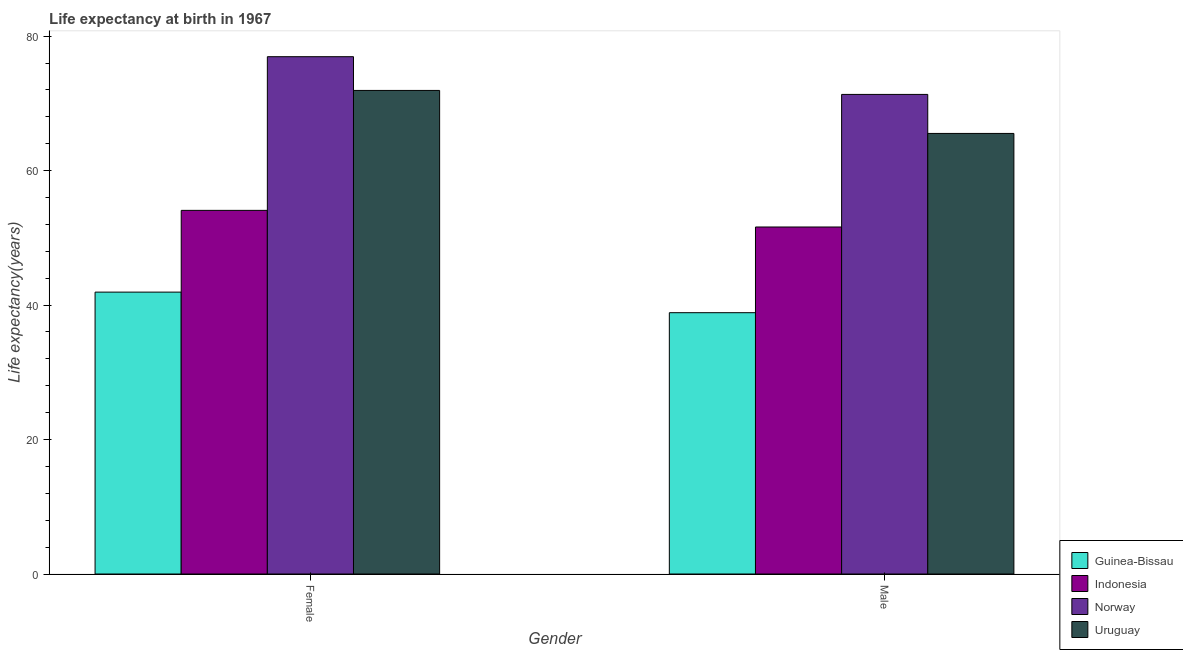How many groups of bars are there?
Provide a short and direct response. 2. What is the label of the 1st group of bars from the left?
Provide a short and direct response. Female. What is the life expectancy(female) in Uruguay?
Your answer should be very brief. 71.92. Across all countries, what is the maximum life expectancy(female)?
Offer a terse response. 76.94. Across all countries, what is the minimum life expectancy(female)?
Make the answer very short. 41.92. In which country was the life expectancy(female) minimum?
Give a very brief answer. Guinea-Bissau. What is the total life expectancy(female) in the graph?
Offer a terse response. 244.87. What is the difference between the life expectancy(male) in Norway and that in Uruguay?
Provide a short and direct response. 5.8. What is the difference between the life expectancy(female) in Guinea-Bissau and the life expectancy(male) in Norway?
Your answer should be very brief. -29.41. What is the average life expectancy(male) per country?
Ensure brevity in your answer.  56.83. What is the difference between the life expectancy(female) and life expectancy(male) in Indonesia?
Your answer should be compact. 2.47. What is the ratio of the life expectancy(male) in Uruguay to that in Guinea-Bissau?
Your response must be concise. 1.69. In how many countries, is the life expectancy(female) greater than the average life expectancy(female) taken over all countries?
Your response must be concise. 2. What does the 2nd bar from the right in Male represents?
Your answer should be very brief. Norway. Are all the bars in the graph horizontal?
Provide a short and direct response. No. Does the graph contain grids?
Keep it short and to the point. No. Where does the legend appear in the graph?
Offer a very short reply. Bottom right. How many legend labels are there?
Your response must be concise. 4. How are the legend labels stacked?
Your answer should be compact. Vertical. What is the title of the graph?
Offer a very short reply. Life expectancy at birth in 1967. What is the label or title of the X-axis?
Provide a succinct answer. Gender. What is the label or title of the Y-axis?
Ensure brevity in your answer.  Life expectancy(years). What is the Life expectancy(years) of Guinea-Bissau in Female?
Give a very brief answer. 41.92. What is the Life expectancy(years) in Indonesia in Female?
Give a very brief answer. 54.08. What is the Life expectancy(years) of Norway in Female?
Provide a short and direct response. 76.94. What is the Life expectancy(years) in Uruguay in Female?
Offer a terse response. 71.92. What is the Life expectancy(years) in Guinea-Bissau in Male?
Give a very brief answer. 38.86. What is the Life expectancy(years) of Indonesia in Male?
Ensure brevity in your answer.  51.61. What is the Life expectancy(years) in Norway in Male?
Your answer should be very brief. 71.33. What is the Life expectancy(years) of Uruguay in Male?
Offer a terse response. 65.53. Across all Gender, what is the maximum Life expectancy(years) of Guinea-Bissau?
Provide a succinct answer. 41.92. Across all Gender, what is the maximum Life expectancy(years) of Indonesia?
Give a very brief answer. 54.08. Across all Gender, what is the maximum Life expectancy(years) in Norway?
Give a very brief answer. 76.94. Across all Gender, what is the maximum Life expectancy(years) of Uruguay?
Provide a succinct answer. 71.92. Across all Gender, what is the minimum Life expectancy(years) in Guinea-Bissau?
Offer a very short reply. 38.86. Across all Gender, what is the minimum Life expectancy(years) in Indonesia?
Your answer should be very brief. 51.61. Across all Gender, what is the minimum Life expectancy(years) of Norway?
Offer a very short reply. 71.33. Across all Gender, what is the minimum Life expectancy(years) of Uruguay?
Your answer should be compact. 65.53. What is the total Life expectancy(years) in Guinea-Bissau in the graph?
Offer a very short reply. 80.79. What is the total Life expectancy(years) in Indonesia in the graph?
Your answer should be very brief. 105.69. What is the total Life expectancy(years) in Norway in the graph?
Provide a succinct answer. 148.27. What is the total Life expectancy(years) in Uruguay in the graph?
Give a very brief answer. 137.45. What is the difference between the Life expectancy(years) of Guinea-Bissau in Female and that in Male?
Your answer should be compact. 3.06. What is the difference between the Life expectancy(years) of Indonesia in Female and that in Male?
Ensure brevity in your answer.  2.47. What is the difference between the Life expectancy(years) of Norway in Female and that in Male?
Keep it short and to the point. 5.61. What is the difference between the Life expectancy(years) in Uruguay in Female and that in Male?
Provide a short and direct response. 6.39. What is the difference between the Life expectancy(years) of Guinea-Bissau in Female and the Life expectancy(years) of Indonesia in Male?
Offer a terse response. -9.69. What is the difference between the Life expectancy(years) of Guinea-Bissau in Female and the Life expectancy(years) of Norway in Male?
Ensure brevity in your answer.  -29.41. What is the difference between the Life expectancy(years) in Guinea-Bissau in Female and the Life expectancy(years) in Uruguay in Male?
Give a very brief answer. -23.6. What is the difference between the Life expectancy(years) in Indonesia in Female and the Life expectancy(years) in Norway in Male?
Make the answer very short. -17.25. What is the difference between the Life expectancy(years) in Indonesia in Female and the Life expectancy(years) in Uruguay in Male?
Give a very brief answer. -11.44. What is the difference between the Life expectancy(years) of Norway in Female and the Life expectancy(years) of Uruguay in Male?
Keep it short and to the point. 11.41. What is the average Life expectancy(years) of Guinea-Bissau per Gender?
Provide a short and direct response. 40.39. What is the average Life expectancy(years) in Indonesia per Gender?
Your response must be concise. 52.85. What is the average Life expectancy(years) of Norway per Gender?
Your answer should be compact. 74.14. What is the average Life expectancy(years) in Uruguay per Gender?
Give a very brief answer. 68.72. What is the difference between the Life expectancy(years) of Guinea-Bissau and Life expectancy(years) of Indonesia in Female?
Offer a very short reply. -12.16. What is the difference between the Life expectancy(years) of Guinea-Bissau and Life expectancy(years) of Norway in Female?
Your answer should be very brief. -35.02. What is the difference between the Life expectancy(years) in Guinea-Bissau and Life expectancy(years) in Uruguay in Female?
Offer a terse response. -30. What is the difference between the Life expectancy(years) in Indonesia and Life expectancy(years) in Norway in Female?
Provide a succinct answer. -22.86. What is the difference between the Life expectancy(years) of Indonesia and Life expectancy(years) of Uruguay in Female?
Provide a short and direct response. -17.84. What is the difference between the Life expectancy(years) of Norway and Life expectancy(years) of Uruguay in Female?
Provide a succinct answer. 5.02. What is the difference between the Life expectancy(years) of Guinea-Bissau and Life expectancy(years) of Indonesia in Male?
Give a very brief answer. -12.75. What is the difference between the Life expectancy(years) in Guinea-Bissau and Life expectancy(years) in Norway in Male?
Keep it short and to the point. -32.47. What is the difference between the Life expectancy(years) of Guinea-Bissau and Life expectancy(years) of Uruguay in Male?
Offer a very short reply. -26.66. What is the difference between the Life expectancy(years) in Indonesia and Life expectancy(years) in Norway in Male?
Provide a short and direct response. -19.72. What is the difference between the Life expectancy(years) of Indonesia and Life expectancy(years) of Uruguay in Male?
Provide a short and direct response. -13.91. What is the difference between the Life expectancy(years) of Norway and Life expectancy(years) of Uruguay in Male?
Keep it short and to the point. 5.8. What is the ratio of the Life expectancy(years) of Guinea-Bissau in Female to that in Male?
Keep it short and to the point. 1.08. What is the ratio of the Life expectancy(years) in Indonesia in Female to that in Male?
Keep it short and to the point. 1.05. What is the ratio of the Life expectancy(years) in Norway in Female to that in Male?
Keep it short and to the point. 1.08. What is the ratio of the Life expectancy(years) of Uruguay in Female to that in Male?
Offer a terse response. 1.1. What is the difference between the highest and the second highest Life expectancy(years) in Guinea-Bissau?
Ensure brevity in your answer.  3.06. What is the difference between the highest and the second highest Life expectancy(years) of Indonesia?
Your response must be concise. 2.47. What is the difference between the highest and the second highest Life expectancy(years) in Norway?
Provide a short and direct response. 5.61. What is the difference between the highest and the second highest Life expectancy(years) of Uruguay?
Offer a very short reply. 6.39. What is the difference between the highest and the lowest Life expectancy(years) in Guinea-Bissau?
Provide a short and direct response. 3.06. What is the difference between the highest and the lowest Life expectancy(years) of Indonesia?
Offer a terse response. 2.47. What is the difference between the highest and the lowest Life expectancy(years) in Norway?
Give a very brief answer. 5.61. What is the difference between the highest and the lowest Life expectancy(years) of Uruguay?
Offer a terse response. 6.39. 